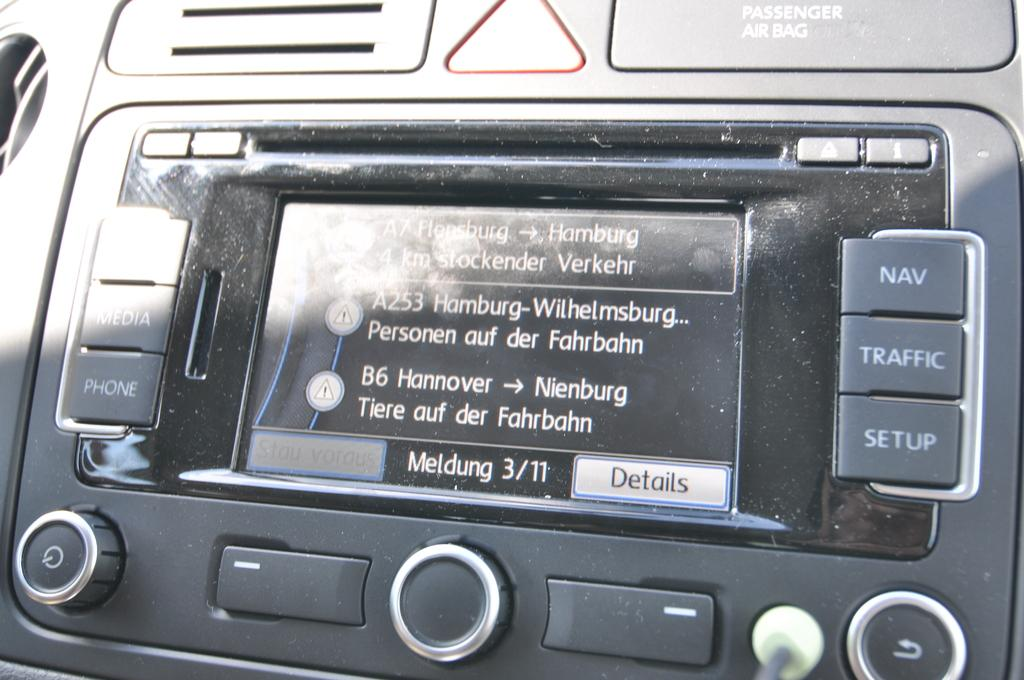What is the main object in the image? There is a screen in the image. Are there any interactive elements on the screen? Yes, there are buttons in the image. What type of umbrella is being used to protect the screen from rain in the image? There is no umbrella present in the image, and the screen is not being protected from rain. 